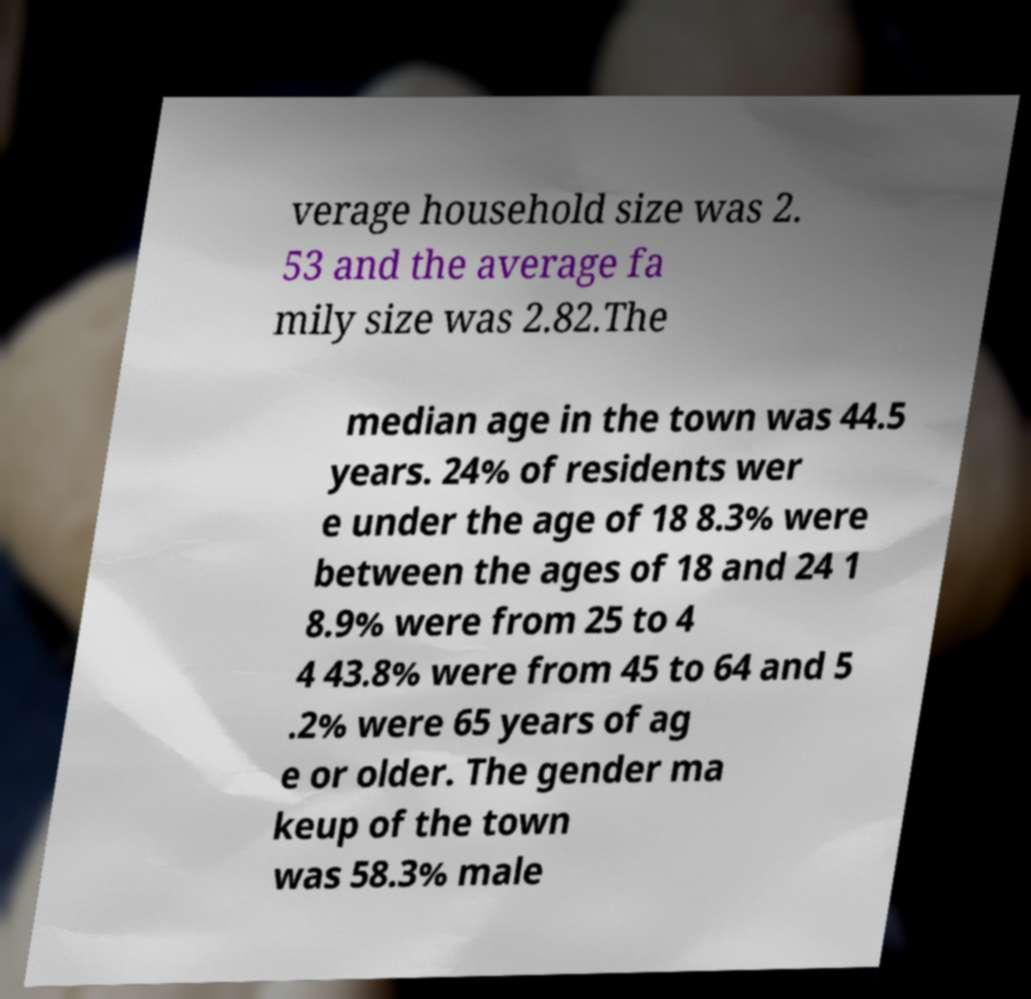Can you accurately transcribe the text from the provided image for me? verage household size was 2. 53 and the average fa mily size was 2.82.The median age in the town was 44.5 years. 24% of residents wer e under the age of 18 8.3% were between the ages of 18 and 24 1 8.9% were from 25 to 4 4 43.8% were from 45 to 64 and 5 .2% were 65 years of ag e or older. The gender ma keup of the town was 58.3% male 